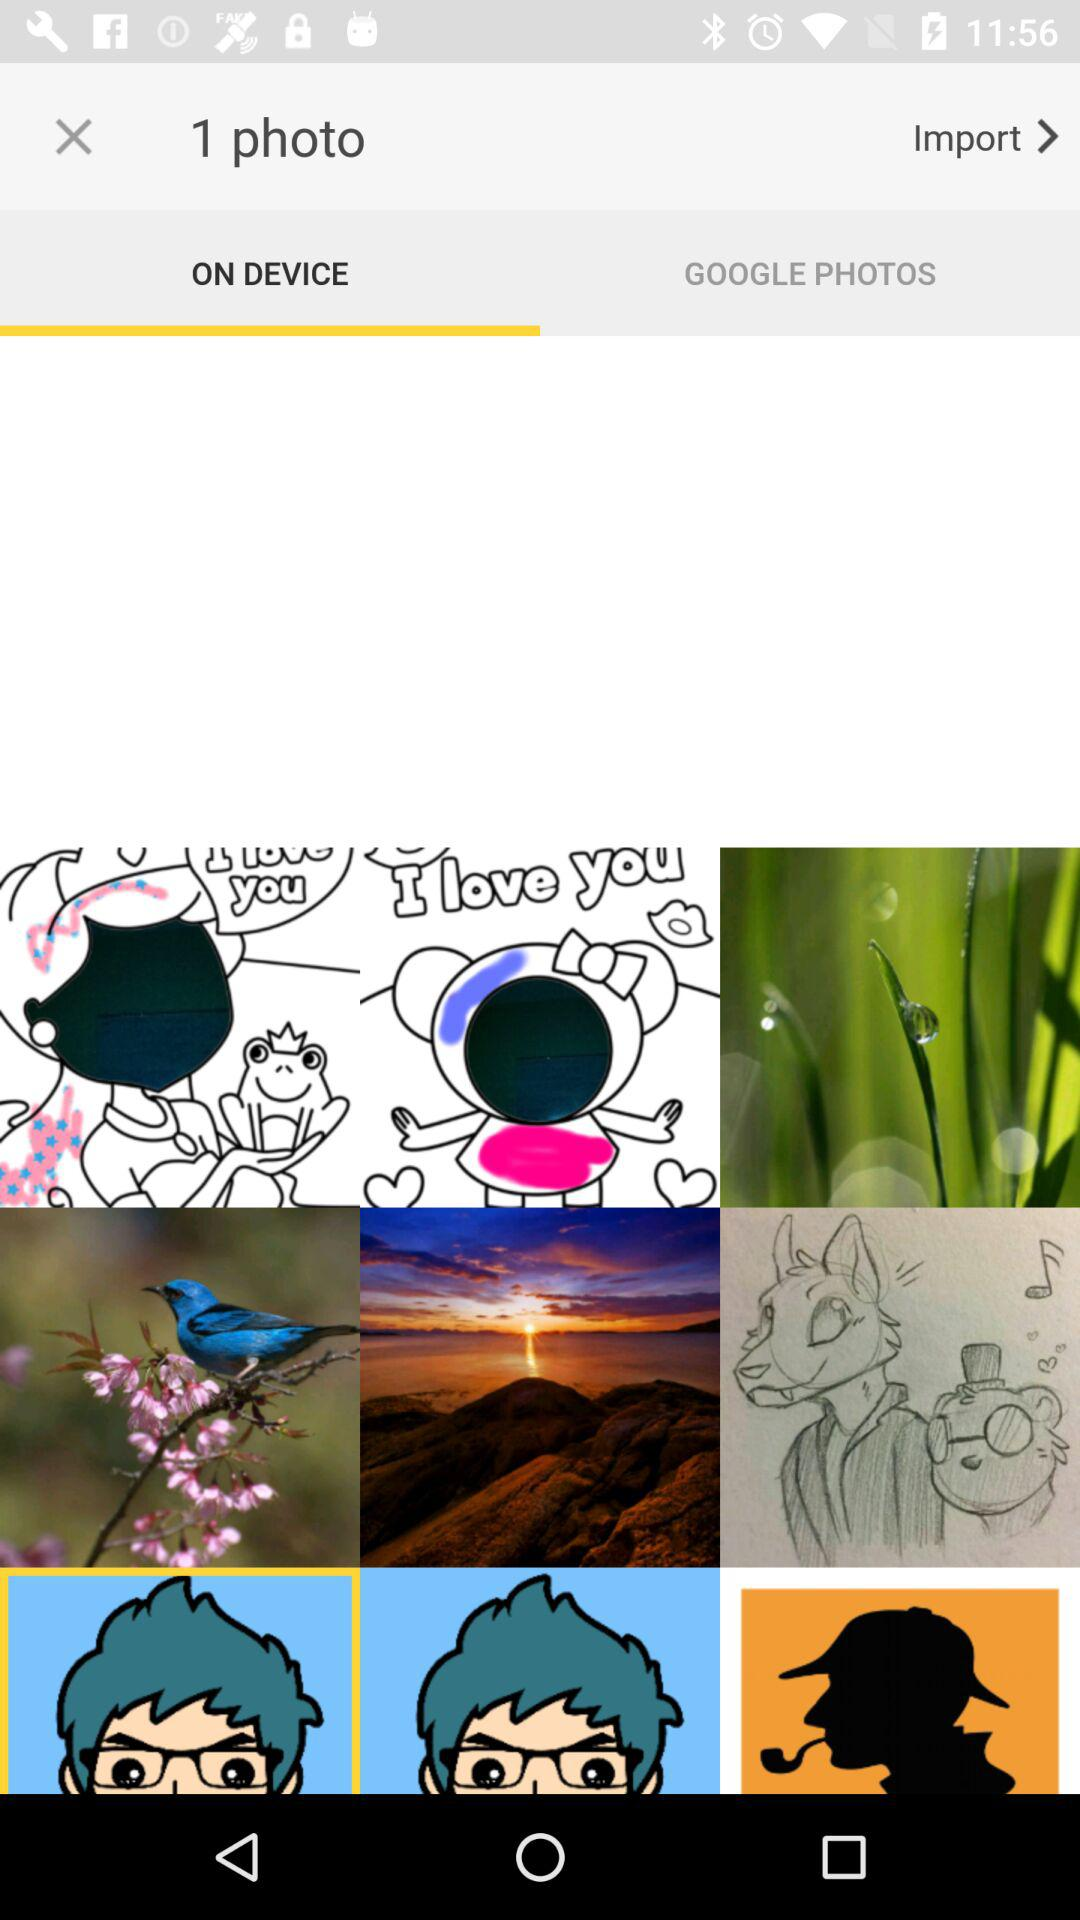What is the number of photo? The number of photo is 1. 